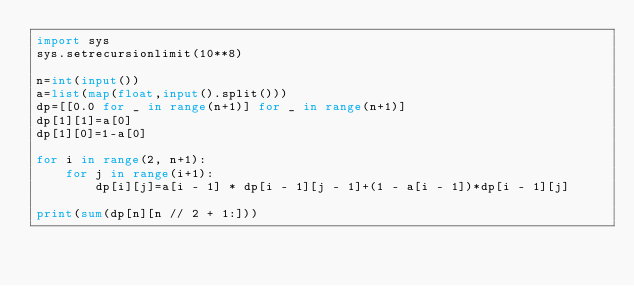<code> <loc_0><loc_0><loc_500><loc_500><_Python_>import sys
sys.setrecursionlimit(10**8)

n=int(input())
a=list(map(float,input().split()))
dp=[[0.0 for _ in range(n+1)] for _ in range(n+1)]
dp[1][1]=a[0]
dp[1][0]=1-a[0]
 
for i in range(2, n+1):
    for j in range(i+1):
        dp[i][j]=a[i - 1] * dp[i - 1][j - 1]+(1 - a[i - 1])*dp[i - 1][j]
 
print(sum(dp[n][n // 2 + 1:]))</code> 